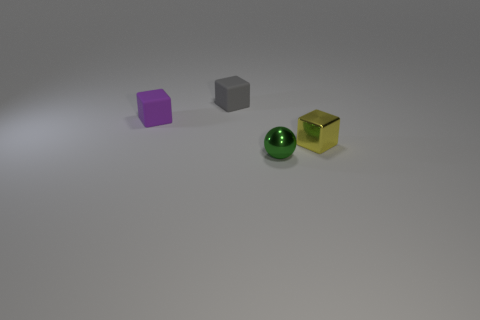Subtract all tiny shiny blocks. How many blocks are left? 2 Add 4 small brown cylinders. How many objects exist? 8 Subtract all purple cubes. How many cubes are left? 2 Subtract 1 blocks. How many blocks are left? 2 Subtract all blue cubes. Subtract all green spheres. How many cubes are left? 3 Subtract all blocks. How many objects are left? 1 Subtract 0 brown cubes. How many objects are left? 4 Subtract all small gray objects. Subtract all large green metallic balls. How many objects are left? 3 Add 4 purple matte cubes. How many purple matte cubes are left? 5 Add 2 green spheres. How many green spheres exist? 3 